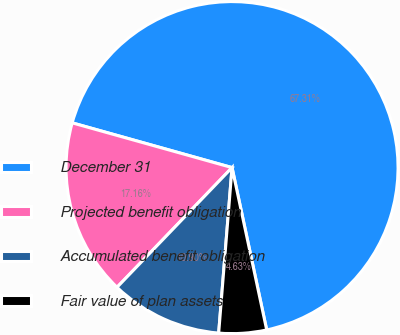<chart> <loc_0><loc_0><loc_500><loc_500><pie_chart><fcel>December 31<fcel>Projected benefit obligation<fcel>Accumulated benefit obligation<fcel>Fair value of plan assets<nl><fcel>67.31%<fcel>17.16%<fcel>10.9%<fcel>4.63%<nl></chart> 